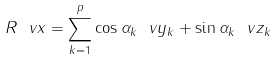<formula> <loc_0><loc_0><loc_500><loc_500>R \ v x = \sum _ { k = 1 } ^ { p } \cos \alpha _ { k } \ v y _ { k } + \sin \alpha _ { k } \ v z _ { k }</formula> 